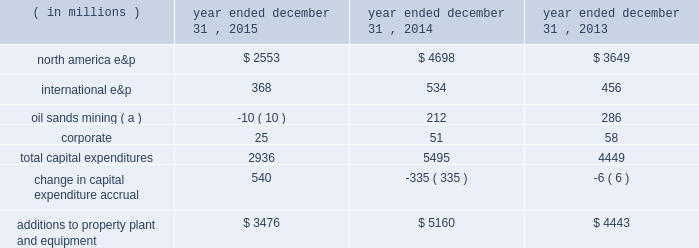Borrowings reflect net proceeds received from the issuance of senior notes in june 2015 .
See liquidity and capital resources below for additional information .
In november 2015 , we repaid our $ 1 billion 0.90% ( 0.90 % ) senior notes upon maturity .
In october 2015 , we announced an adjustment to our quarterly dividend .
See capital requirements below for additional information .
Additions to property , plant and equipment are our most significant use of cash and cash equivalents .
The table shows capital expenditures related to continuing operations by segment and reconciles to additions to property , plant and equipment as presented in the consolidated statements of cash flows for 2015 , 2014 and 2013: .
( a ) reflects reimbursements earned from the governments of canada and alberta related to funds previously expended for quest ccs capital equipment .
Quest ccs was successfully completed and commissioned in the fourth quarter of 2015 .
During 2014 , we acquired 29 million shares at a cost of $ 1 billion and in 2013 acquired 14 million shares at a cost of $ 500 million .
There were no share repurchases in 2015 .
See item 8 .
Financial statements and supplementary data 2013 note 23 to the consolidated financial statements for discussion of purchases of common stock .
Liquidity and capital resources on june 10 , 2015 , we issued $ 2 billion aggregate principal amount of unsecured senior notes which consist of the following series : 2022 $ 600 million of 2.70% ( 2.70 % ) senior notes due june 1 , 2020 2022 $ 900 million of 3.85% ( 3.85 % ) senior notes due june 1 , 2025 2022 $ 500 million of 5.20% ( 5.20 % ) senior notes due june 1 , 2045 interest on each series of senior notes is payable semi-annually beginning december 1 , 2015 .
We used the aggregate net proceeds to repay our $ 1 billion 0.90% ( 0.90 % ) senior notes on november 2 , 2015 , and the remainder for general corporate purposes .
In may 2015 , we amended our $ 2.5 billion credit facility to increase the facility size by $ 500 million to a total of $ 3.0 billion and extend the maturity date by an additional year such that the credit facility now matures in may 2020 .
The amendment additionally provides us the ability to request two one-year extensions to the maturity date and an option to increase the commitment amount by up to an additional $ 500 million , subject to the consent of any increasing lenders .
The sub-facilities for swing-line loans and letters of credit remain unchanged allowing up to an aggregate amount of $ 100 million and $ 500 million , respectively .
Fees on the unused commitment of each lender , as well as the borrowing options under the credit facility , remain unchanged .
Our main sources of liquidity are cash and cash equivalents , internally generated cash flow from operations , capital market transactions , our committed revolving credit facility and sales of non-core assets .
Our working capital requirements are supported by these sources and we may issue either commercial paper backed by our $ 3.0 billion revolving credit facility or draw on our $ 3.0 billion revolving credit facility to meet short-term cash requirements or issue debt or equity securities through the shelf registration statement discussed below as part of our longer-term liquidity and capital management .
Because of the alternatives available to us as discussed above , we believe that our short-term and long-term liquidity is adequate to fund not only our current operations , but also our near-term and long-term funding requirements including our capital spending programs , dividend payments , defined benefit plan contributions , repayment of debt maturities and other amounts that may ultimately be paid in connection with contingencies .
General economic conditions , commodity prices , and financial , business and other factors could affect our operations and our ability to access the capital markets .
A downgrade in our credit ratings could negatively impact our cost of capital and our ability to access the capital markets , increase the interest rate and fees we pay on our unsecured revolving credit facility , restrict our access to the commercial paper market , or require us to post letters of credit or other forms of collateral for certain .
What were average yearly capital expenditures for corporate , in millions? 
Computations: table_average(corporate, none)
Answer: 44.66667. 